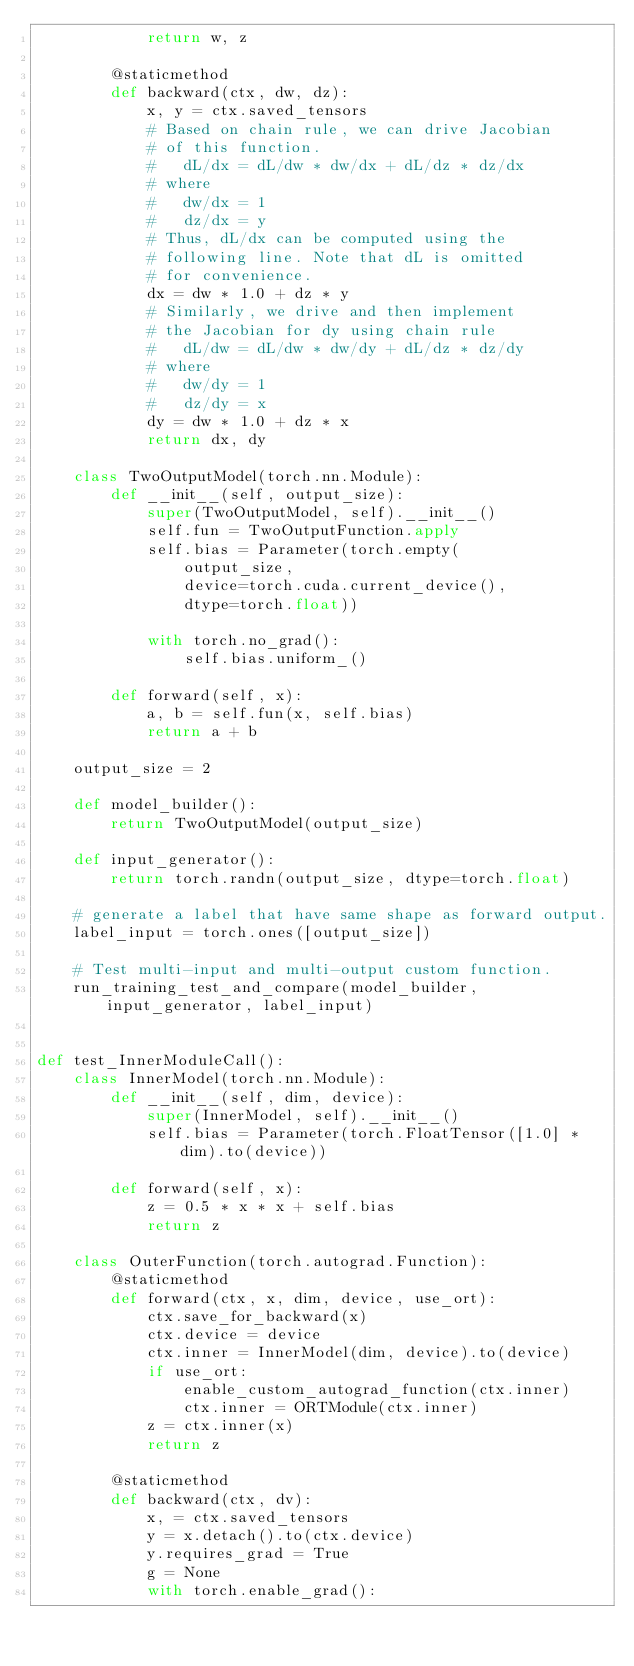Convert code to text. <code><loc_0><loc_0><loc_500><loc_500><_Python_>            return w, z

        @staticmethod
        def backward(ctx, dw, dz):
            x, y = ctx.saved_tensors
            # Based on chain rule, we can drive Jacobian
            # of this function.
            #   dL/dx = dL/dw * dw/dx + dL/dz * dz/dx
            # where
            #   dw/dx = 1
            #   dz/dx = y
            # Thus, dL/dx can be computed using the
            # following line. Note that dL is omitted
            # for convenience.
            dx = dw * 1.0 + dz * y
            # Similarly, we drive and then implement
            # the Jacobian for dy using chain rule
            #   dL/dw = dL/dw * dw/dy + dL/dz * dz/dy
            # where
            #   dw/dy = 1
            #   dz/dy = x
            dy = dw * 1.0 + dz * x
            return dx, dy

    class TwoOutputModel(torch.nn.Module):
        def __init__(self, output_size):
            super(TwoOutputModel, self).__init__()
            self.fun = TwoOutputFunction.apply
            self.bias = Parameter(torch.empty(
                output_size,
                device=torch.cuda.current_device(),
                dtype=torch.float))

            with torch.no_grad():
                self.bias.uniform_()

        def forward(self, x):
            a, b = self.fun(x, self.bias)
            return a + b

    output_size = 2

    def model_builder():
        return TwoOutputModel(output_size)

    def input_generator():
        return torch.randn(output_size, dtype=torch.float)

    # generate a label that have same shape as forward output.
    label_input = torch.ones([output_size])

    # Test multi-input and multi-output custom function.
    run_training_test_and_compare(model_builder, input_generator, label_input)


def test_InnerModuleCall():
    class InnerModel(torch.nn.Module):
        def __init__(self, dim, device):
            super(InnerModel, self).__init__()
            self.bias = Parameter(torch.FloatTensor([1.0] * dim).to(device))

        def forward(self, x):
            z = 0.5 * x * x + self.bias
            return z

    class OuterFunction(torch.autograd.Function):
        @staticmethod
        def forward(ctx, x, dim, device, use_ort):
            ctx.save_for_backward(x)
            ctx.device = device
            ctx.inner = InnerModel(dim, device).to(device)
            if use_ort:
                enable_custom_autograd_function(ctx.inner)
                ctx.inner = ORTModule(ctx.inner)
            z = ctx.inner(x)
            return z

        @staticmethod
        def backward(ctx, dv):
            x, = ctx.saved_tensors
            y = x.detach().to(ctx.device)
            y.requires_grad = True
            g = None
            with torch.enable_grad():</code> 